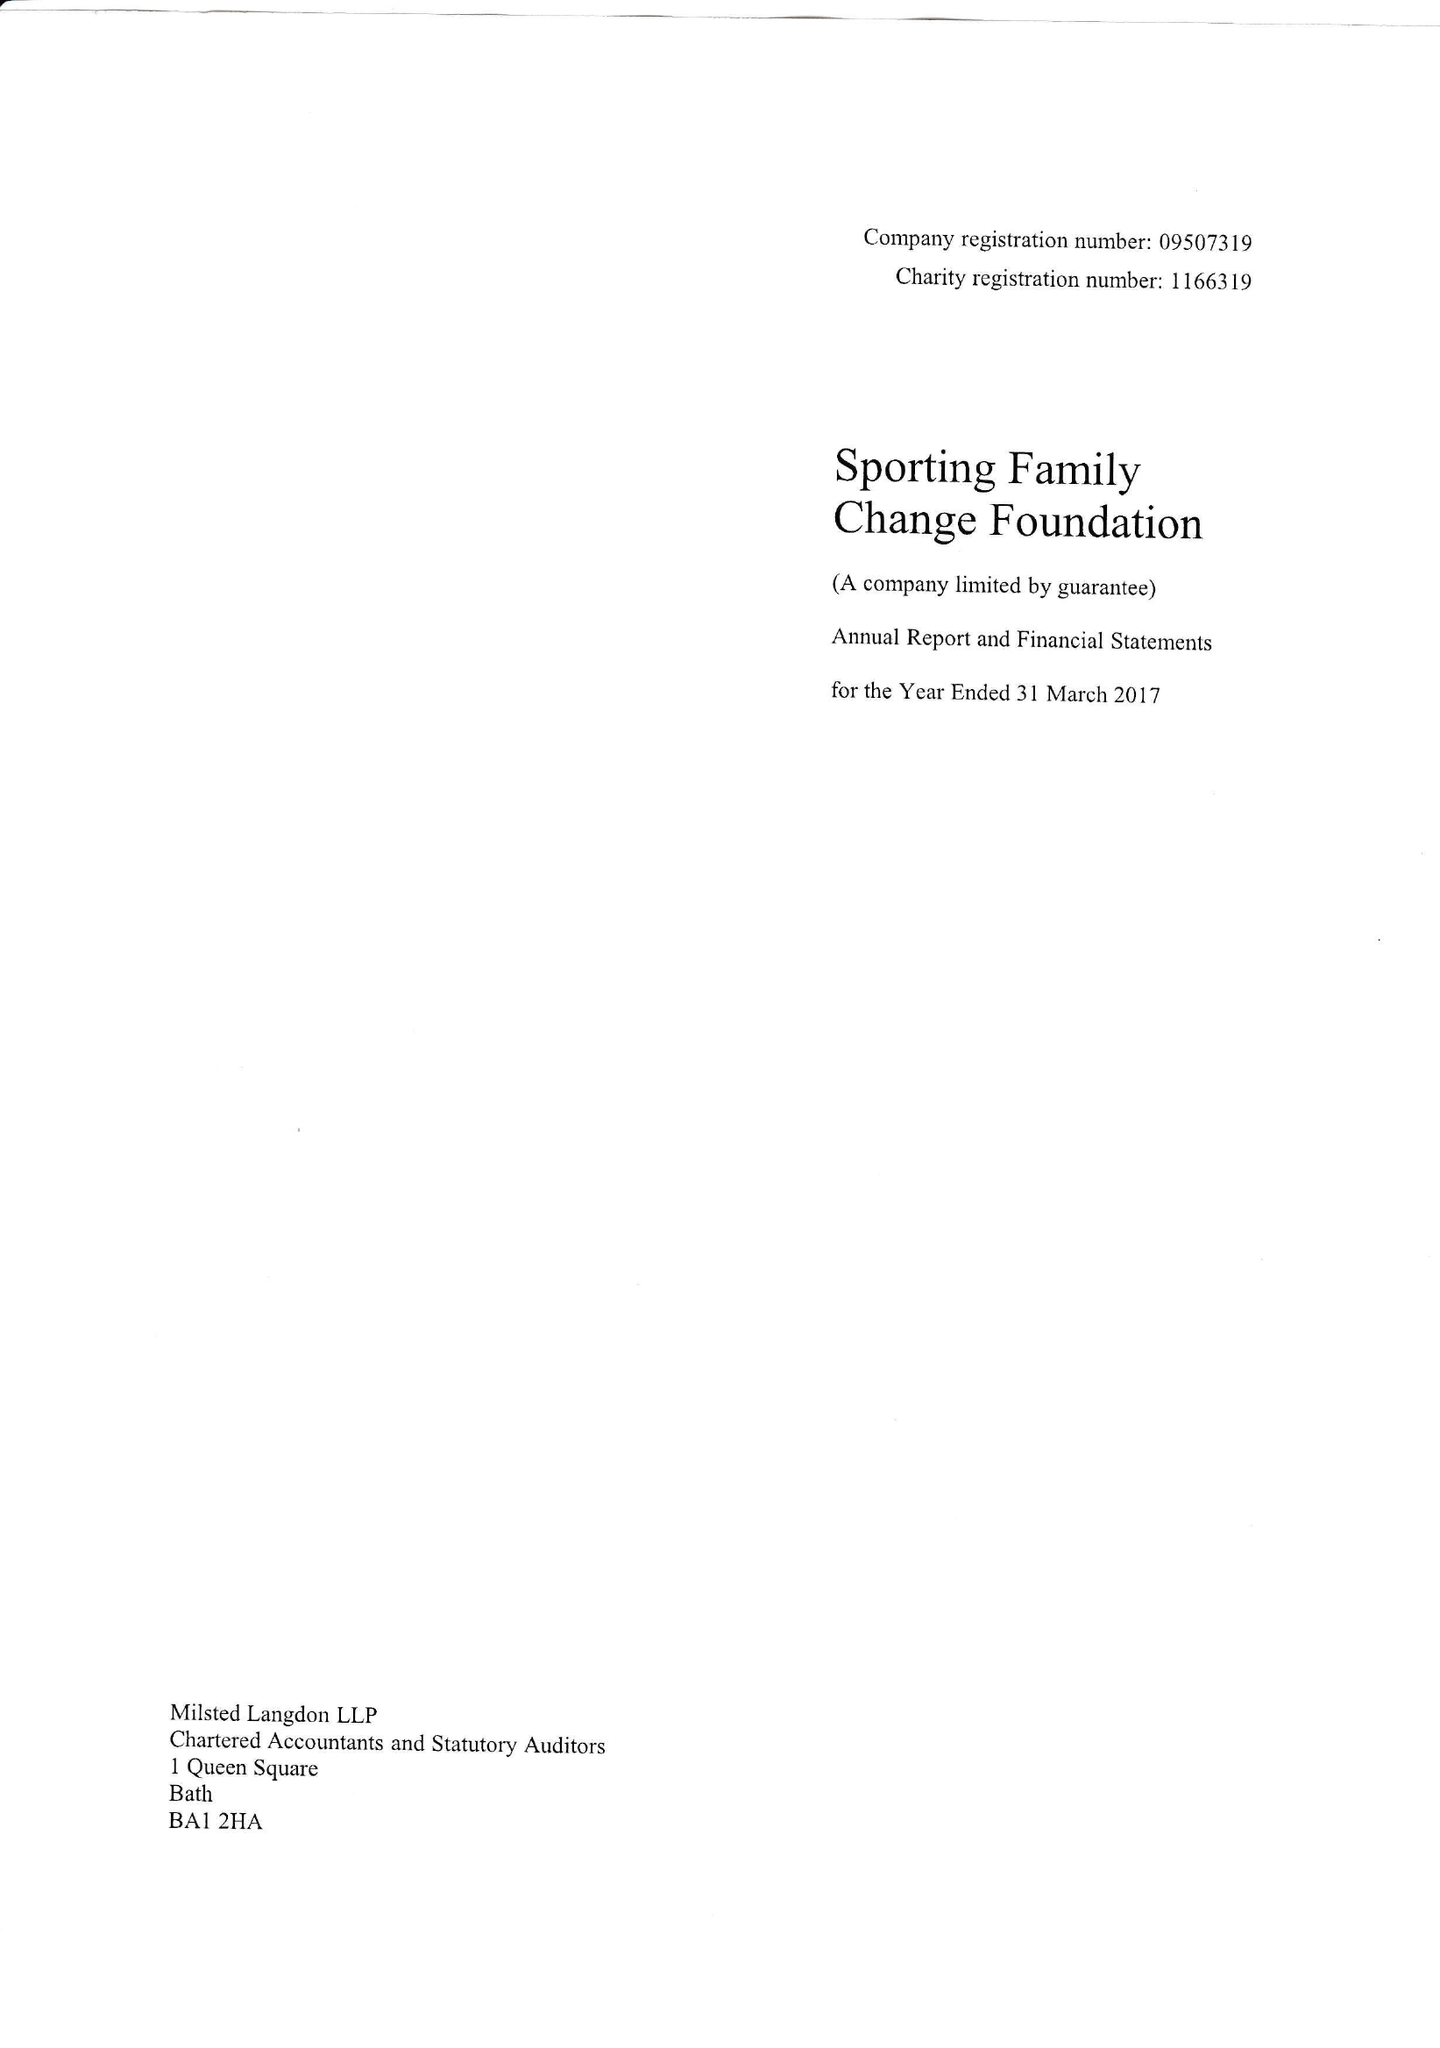What is the value for the address__street_line?
Answer the question using a single word or phrase. 4 HAZLETON GARDENS 